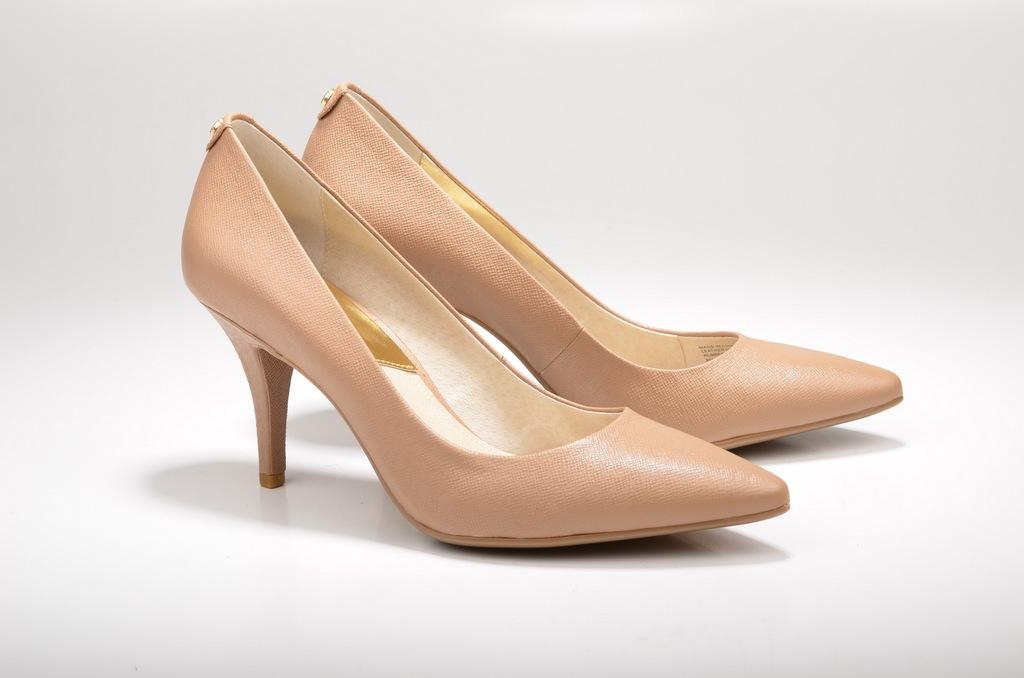What type of footwear is featured in the image? There are heel pumps in the image. Can you describe the colors of the heel pumps? The heel pumps are of gold and cream color. Where is the throne located in the image? There is no throne present in the image; it only features heel pumps.s of gold and cream color. 